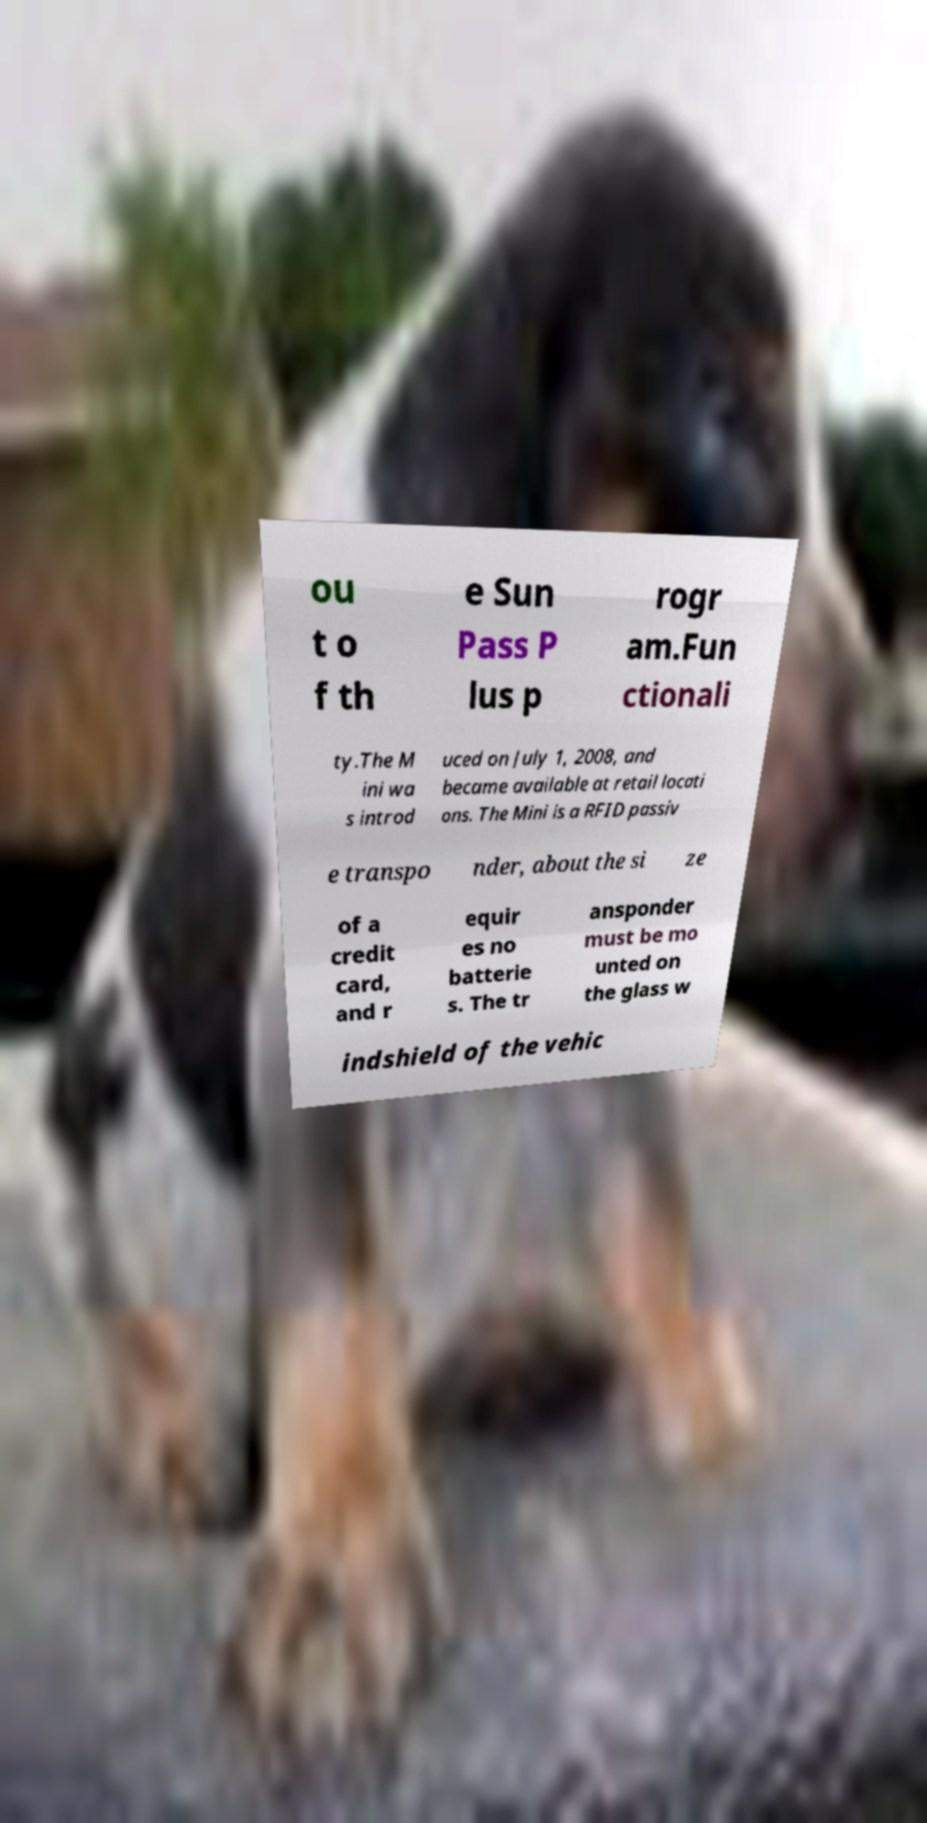There's text embedded in this image that I need extracted. Can you transcribe it verbatim? ou t o f th e Sun Pass P lus p rogr am.Fun ctionali ty.The M ini wa s introd uced on July 1, 2008, and became available at retail locati ons. The Mini is a RFID passiv e transpo nder, about the si ze of a credit card, and r equir es no batterie s. The tr ansponder must be mo unted on the glass w indshield of the vehic 